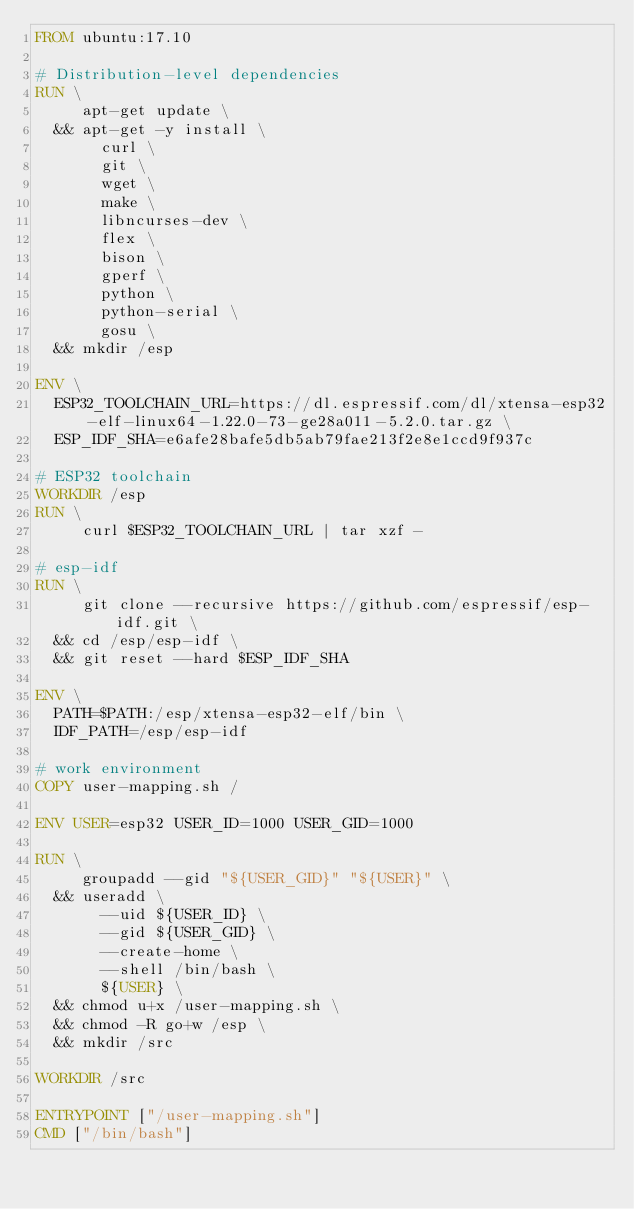Convert code to text. <code><loc_0><loc_0><loc_500><loc_500><_Dockerfile_>FROM ubuntu:17.10

# Distribution-level dependencies
RUN \
     apt-get update \
  && apt-get -y install \
       curl \
       git \
       wget \
       make \
       libncurses-dev \
       flex \
       bison \
       gperf \
       python \
       python-serial \
       gosu \
  && mkdir /esp

ENV \
  ESP32_TOOLCHAIN_URL=https://dl.espressif.com/dl/xtensa-esp32-elf-linux64-1.22.0-73-ge28a011-5.2.0.tar.gz \
  ESP_IDF_SHA=e6afe28bafe5db5ab79fae213f2e8e1ccd9f937c

# ESP32 toolchain
WORKDIR /esp
RUN \
     curl $ESP32_TOOLCHAIN_URL | tar xzf -

# esp-idf
RUN \
     git clone --recursive https://github.com/espressif/esp-idf.git \
  && cd /esp/esp-idf \
  && git reset --hard $ESP_IDF_SHA

ENV \
  PATH=$PATH:/esp/xtensa-esp32-elf/bin \
  IDF_PATH=/esp/esp-idf

# work environment
COPY user-mapping.sh /

ENV USER=esp32 USER_ID=1000 USER_GID=1000

RUN \
     groupadd --gid "${USER_GID}" "${USER}" \
  && useradd \
       --uid ${USER_ID} \
       --gid ${USER_GID} \
       --create-home \
       --shell /bin/bash \
       ${USER} \
  && chmod u+x /user-mapping.sh \
  && chmod -R go+w /esp \
  && mkdir /src

WORKDIR /src

ENTRYPOINT ["/user-mapping.sh"]
CMD ["/bin/bash"]
</code> 